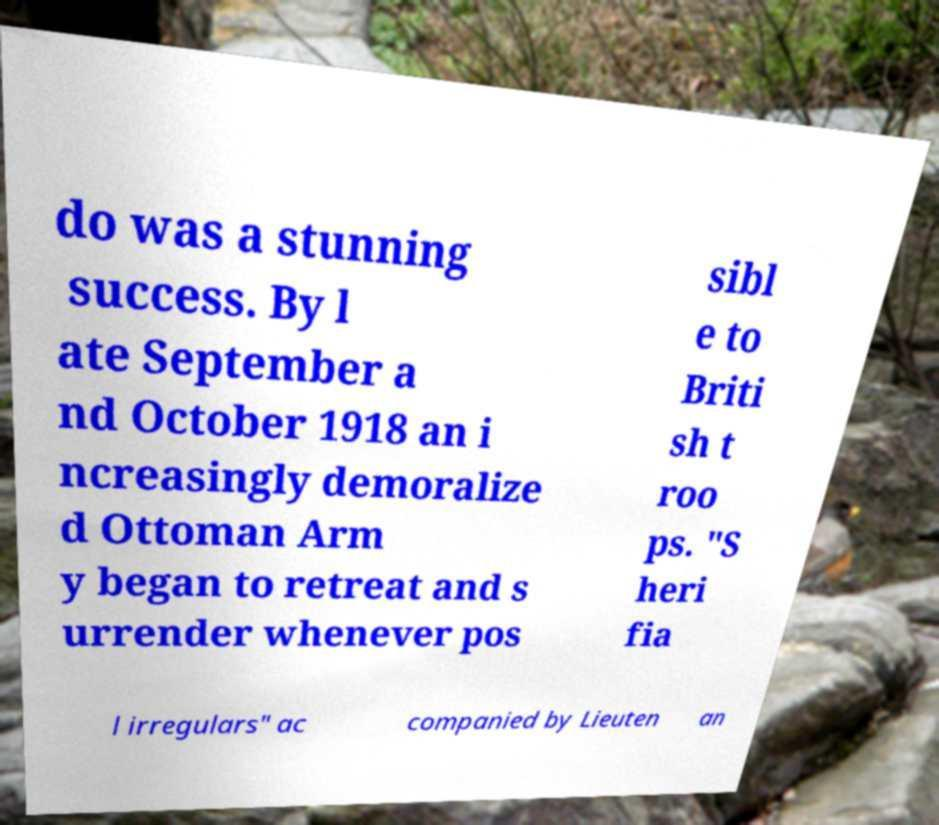Can you read and provide the text displayed in the image?This photo seems to have some interesting text. Can you extract and type it out for me? do was a stunning success. By l ate September a nd October 1918 an i ncreasingly demoralize d Ottoman Arm y began to retreat and s urrender whenever pos sibl e to Briti sh t roo ps. "S heri fia l irregulars" ac companied by Lieuten an 